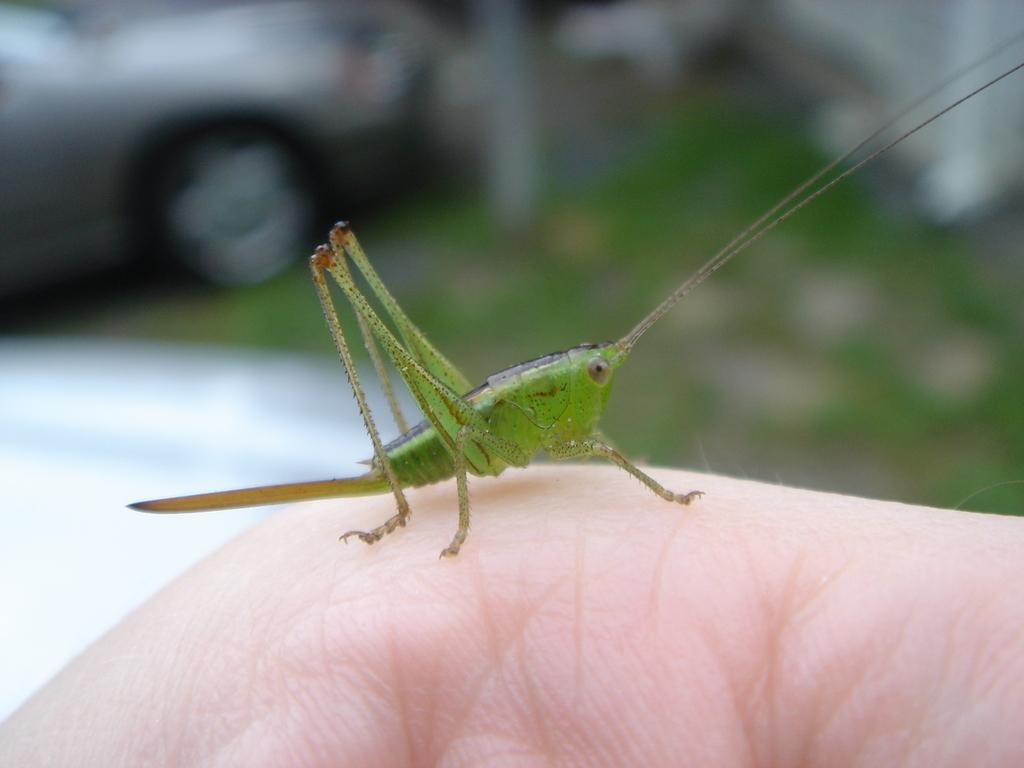In one or two sentences, can you explain what this image depicts? In this picture we can see an insect on a person hand and in the background we can see a car, grass and it is blurry. 